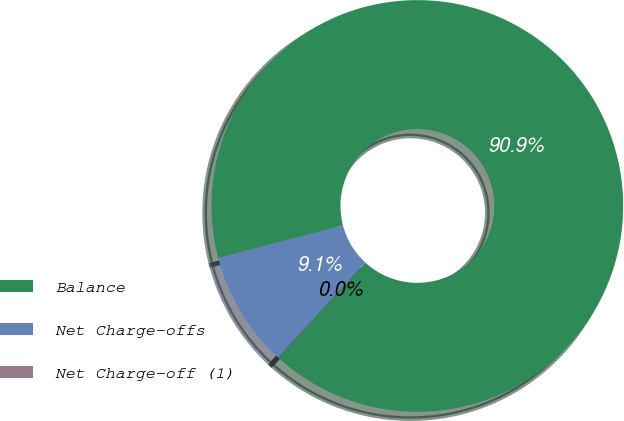Convert chart. <chart><loc_0><loc_0><loc_500><loc_500><pie_chart><fcel>Balance<fcel>Net Charge-offs<fcel>Net Charge-off (1)<nl><fcel>90.88%<fcel>9.1%<fcel>0.02%<nl></chart> 